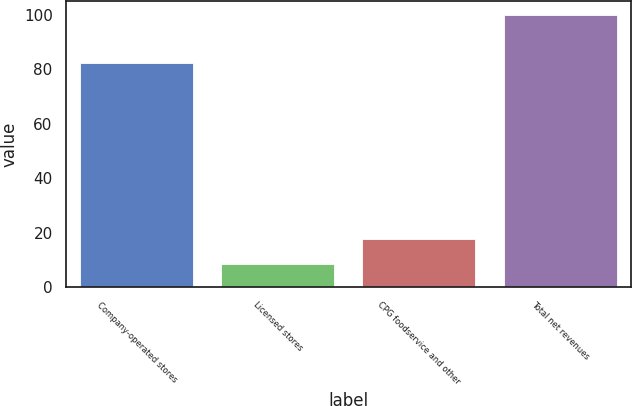<chart> <loc_0><loc_0><loc_500><loc_500><bar_chart><fcel>Company-operated stores<fcel>Licensed stores<fcel>CPG foodservice and other<fcel>Total net revenues<nl><fcel>82.3<fcel>8.6<fcel>17.74<fcel>100<nl></chart> 